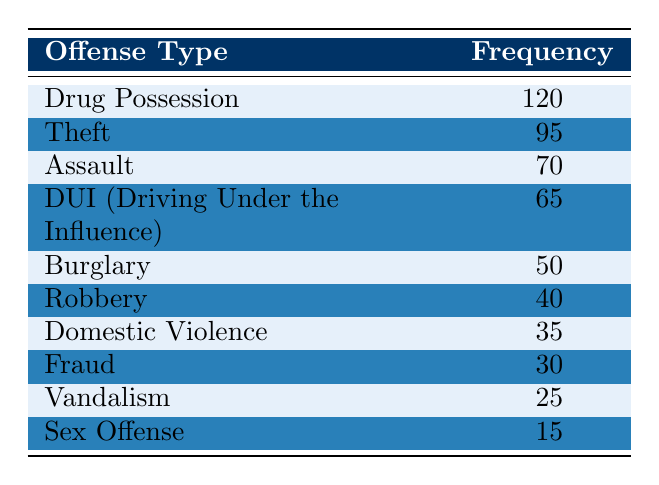What is the most common offense type among repeat offenders in 2022? The table indicates that "Drug Possession" has the highest frequency of 120, making it the most common offense type.
Answer: Drug Possession How many repeat offenders committed Theft in 2022? Referring to the table, the frequency for "Theft" is listed as 95.
Answer: 95 What is the total frequency of Assault and Domestic Violence offenses? To find the total frequency, add the counts for "Assault" (70) and "Domestic Violence" (35), resulting in 70 + 35 = 105.
Answer: 105 True or False: More repeat offenders committed Vandalism than Sex Offense in 2022. The table shows "Vandalism" at 25 and "Sex Offense" at 15. Since 25 is greater than 15, the statement is true.
Answer: True What is the average frequency of the top three most common offenses? The top three offenses are "Drug Possession" (120), "Theft" (95), and "Assault" (70). Calculate the sum: 120 + 95 + 70 = 285. Then, divide by 3 for the average: 285 / 3 = 95.
Answer: 95 How many more repeat offenders committed DUI than Robbery? The table shows "DUI" has a count of 65 and "Robbery" has 40. Subtract Robbery from DUI: 65 - 40 = 25.
Answer: 25 Which offense has the lowest frequency among repeat offenders? Looking at the table, "Sex Offense" shows the lowest frequency with a count of 15, identifying it as the least common offense.
Answer: Sex Offense What is the total number of offenses committed by repeat offenders in 2022? To determine the total, sum all offense counts: 120 + 95 + 70 + 65 + 50 + 40 + 35 + 30 + 25 + 15 =  525.
Answer: 525 Which offense type has a frequency between 30 and 70? Reviewing the table, "Domestic Violence" (35) and "DUI" (65) fall within that range, confirming there are two such offense types.
Answer: Domestic Violence, DUI 